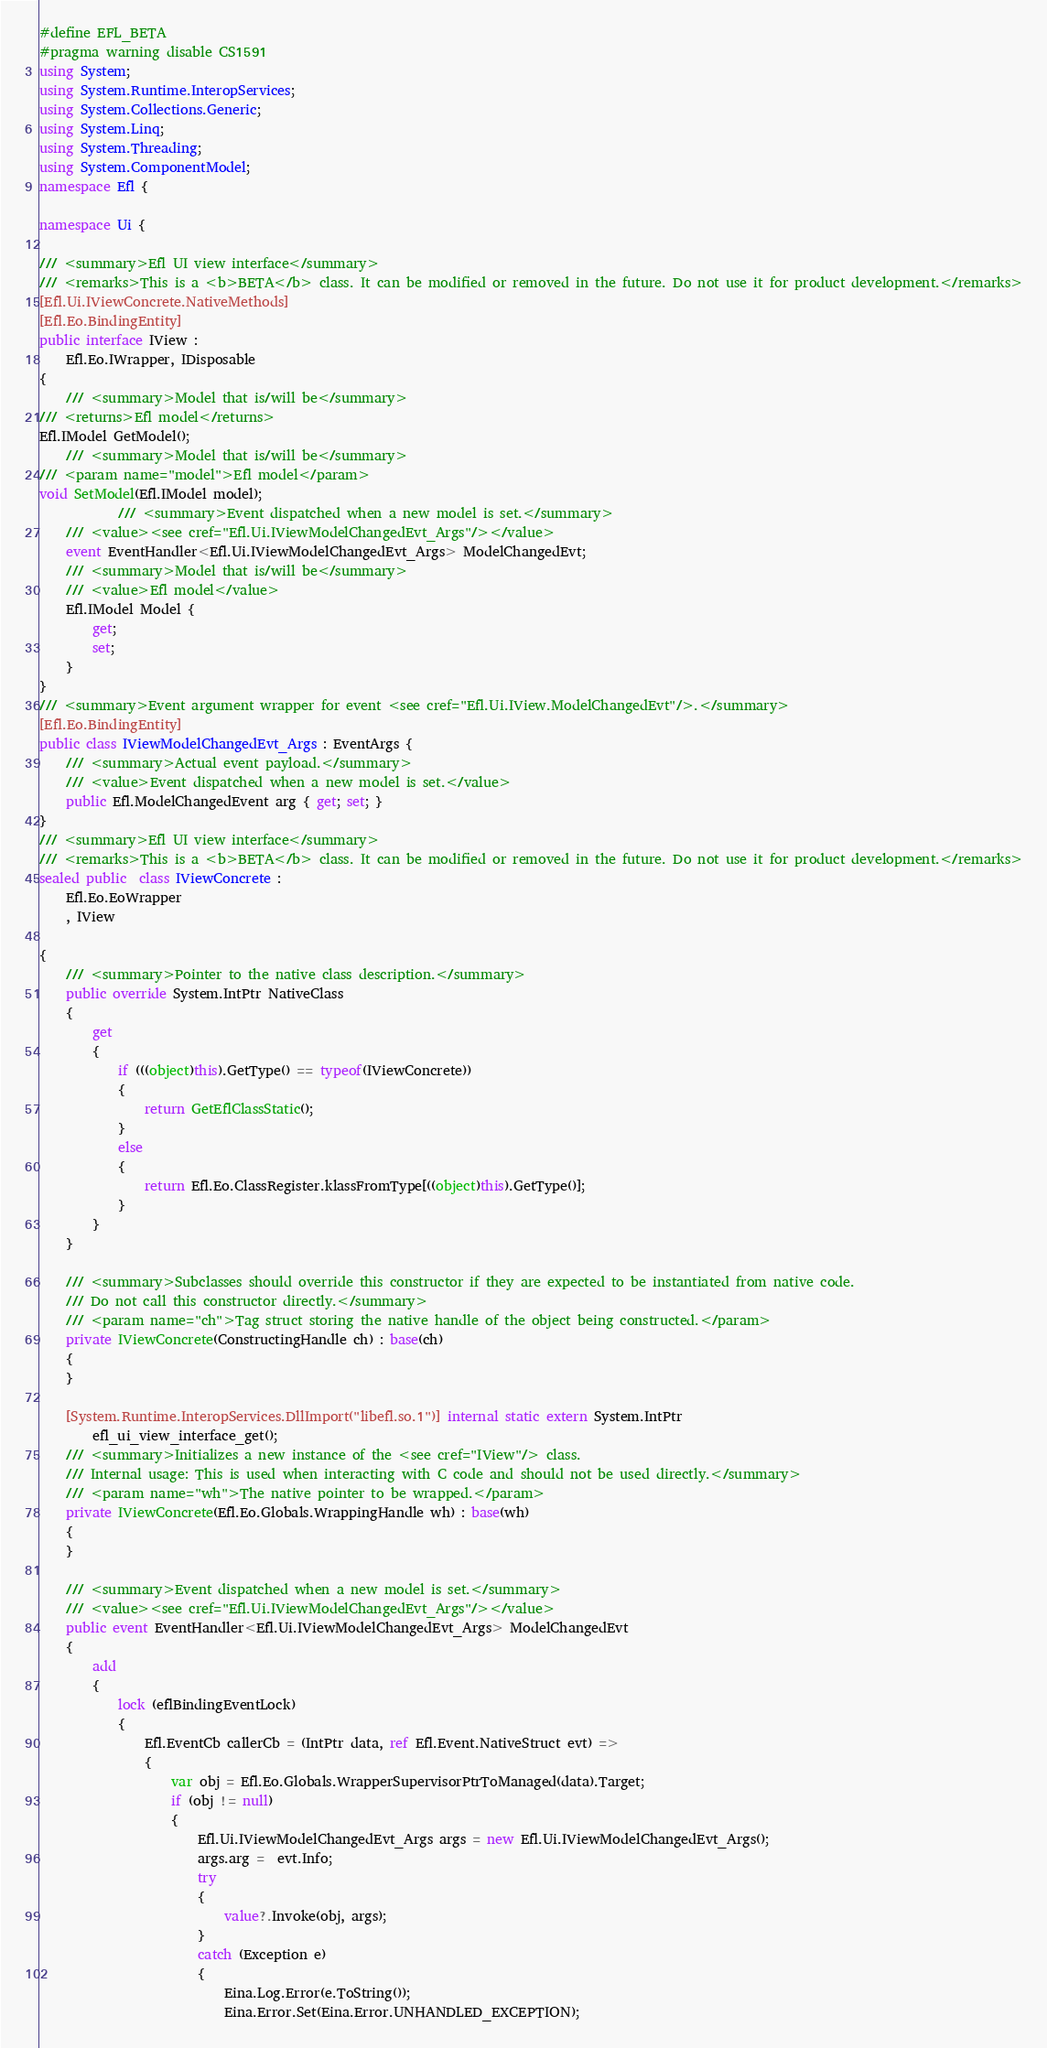Convert code to text. <code><loc_0><loc_0><loc_500><loc_500><_C#_>#define EFL_BETA
#pragma warning disable CS1591
using System;
using System.Runtime.InteropServices;
using System.Collections.Generic;
using System.Linq;
using System.Threading;
using System.ComponentModel;
namespace Efl {

namespace Ui {

/// <summary>Efl UI view interface</summary>
/// <remarks>This is a <b>BETA</b> class. It can be modified or removed in the future. Do not use it for product development.</remarks>
[Efl.Ui.IViewConcrete.NativeMethods]
[Efl.Eo.BindingEntity]
public interface IView : 
    Efl.Eo.IWrapper, IDisposable
{
    /// <summary>Model that is/will be</summary>
/// <returns>Efl model</returns>
Efl.IModel GetModel();
    /// <summary>Model that is/will be</summary>
/// <param name="model">Efl model</param>
void SetModel(Efl.IModel model);
            /// <summary>Event dispatched when a new model is set.</summary>
    /// <value><see cref="Efl.Ui.IViewModelChangedEvt_Args"/></value>
    event EventHandler<Efl.Ui.IViewModelChangedEvt_Args> ModelChangedEvt;
    /// <summary>Model that is/will be</summary>
    /// <value>Efl model</value>
    Efl.IModel Model {
        get;
        set;
    }
}
/// <summary>Event argument wrapper for event <see cref="Efl.Ui.IView.ModelChangedEvt"/>.</summary>
[Efl.Eo.BindingEntity]
public class IViewModelChangedEvt_Args : EventArgs {
    /// <summary>Actual event payload.</summary>
    /// <value>Event dispatched when a new model is set.</value>
    public Efl.ModelChangedEvent arg { get; set; }
}
/// <summary>Efl UI view interface</summary>
/// <remarks>This is a <b>BETA</b> class. It can be modified or removed in the future. Do not use it for product development.</remarks>
sealed public  class IViewConcrete :
    Efl.Eo.EoWrapper
    , IView
    
{
    /// <summary>Pointer to the native class description.</summary>
    public override System.IntPtr NativeClass
    {
        get
        {
            if (((object)this).GetType() == typeof(IViewConcrete))
            {
                return GetEflClassStatic();
            }
            else
            {
                return Efl.Eo.ClassRegister.klassFromType[((object)this).GetType()];
            }
        }
    }

    /// <summary>Subclasses should override this constructor if they are expected to be instantiated from native code.
    /// Do not call this constructor directly.</summary>
    /// <param name="ch">Tag struct storing the native handle of the object being constructed.</param>
    private IViewConcrete(ConstructingHandle ch) : base(ch)
    {
    }

    [System.Runtime.InteropServices.DllImport("libefl.so.1")] internal static extern System.IntPtr
        efl_ui_view_interface_get();
    /// <summary>Initializes a new instance of the <see cref="IView"/> class.
    /// Internal usage: This is used when interacting with C code and should not be used directly.</summary>
    /// <param name="wh">The native pointer to be wrapped.</param>
    private IViewConcrete(Efl.Eo.Globals.WrappingHandle wh) : base(wh)
    {
    }

    /// <summary>Event dispatched when a new model is set.</summary>
    /// <value><see cref="Efl.Ui.IViewModelChangedEvt_Args"/></value>
    public event EventHandler<Efl.Ui.IViewModelChangedEvt_Args> ModelChangedEvt
    {
        add
        {
            lock (eflBindingEventLock)
            {
                Efl.EventCb callerCb = (IntPtr data, ref Efl.Event.NativeStruct evt) =>
                {
                    var obj = Efl.Eo.Globals.WrapperSupervisorPtrToManaged(data).Target;
                    if (obj != null)
                    {
                        Efl.Ui.IViewModelChangedEvt_Args args = new Efl.Ui.IViewModelChangedEvt_Args();
                        args.arg =  evt.Info;
                        try
                        {
                            value?.Invoke(obj, args);
                        }
                        catch (Exception e)
                        {
                            Eina.Log.Error(e.ToString());
                            Eina.Error.Set(Eina.Error.UNHANDLED_EXCEPTION);</code> 